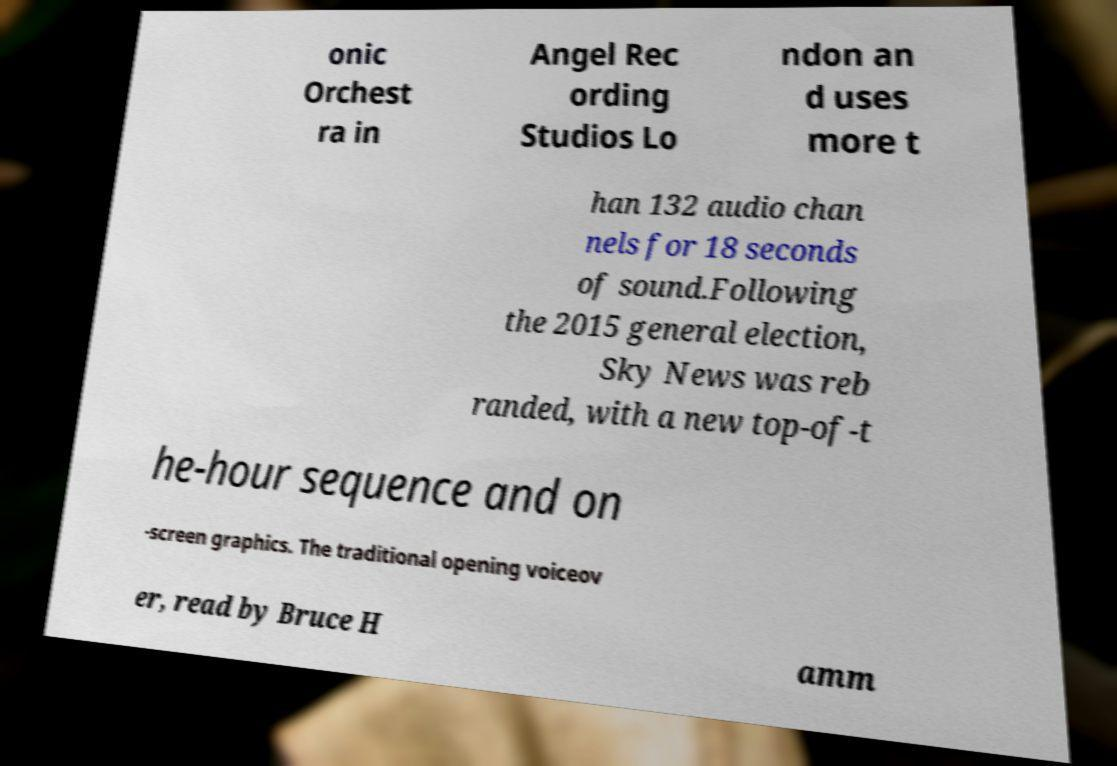There's text embedded in this image that I need extracted. Can you transcribe it verbatim? onic Orchest ra in Angel Rec ording Studios Lo ndon an d uses more t han 132 audio chan nels for 18 seconds of sound.Following the 2015 general election, Sky News was reb randed, with a new top-of-t he-hour sequence and on -screen graphics. The traditional opening voiceov er, read by Bruce H amm 